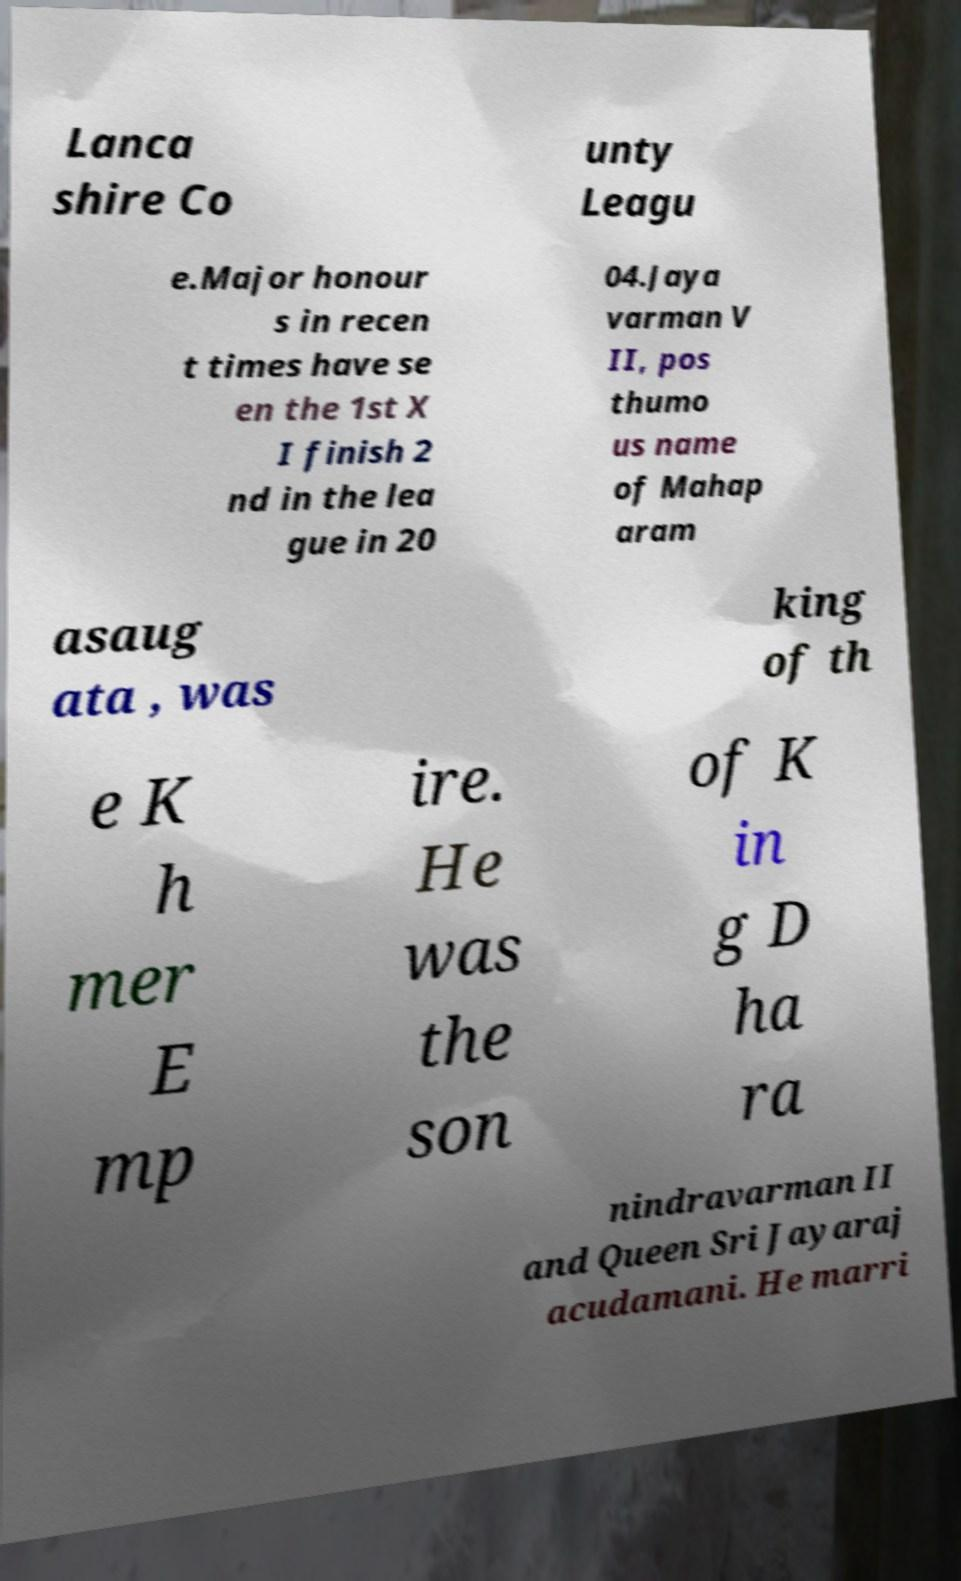Could you assist in decoding the text presented in this image and type it out clearly? Lanca shire Co unty Leagu e.Major honour s in recen t times have se en the 1st X I finish 2 nd in the lea gue in 20 04.Jaya varman V II, pos thumo us name of Mahap aram asaug ata , was king of th e K h mer E mp ire. He was the son of K in g D ha ra nindravarman II and Queen Sri Jayaraj acudamani. He marri 